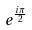<formula> <loc_0><loc_0><loc_500><loc_500>e ^ { \frac { i \pi } { 2 } }</formula> 